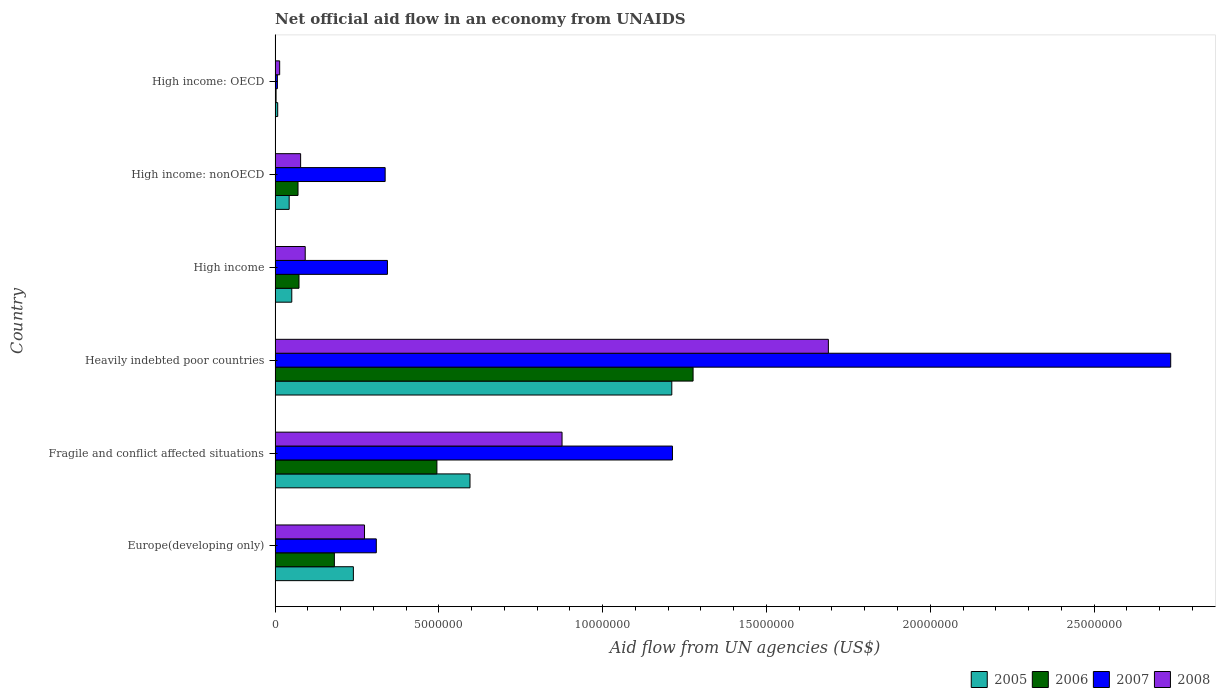Are the number of bars per tick equal to the number of legend labels?
Your answer should be very brief. Yes. How many bars are there on the 6th tick from the top?
Offer a very short reply. 4. How many bars are there on the 1st tick from the bottom?
Offer a terse response. 4. What is the label of the 6th group of bars from the top?
Offer a terse response. Europe(developing only). In how many cases, is the number of bars for a given country not equal to the number of legend labels?
Provide a succinct answer. 0. What is the net official aid flow in 2006 in Europe(developing only)?
Make the answer very short. 1.81e+06. Across all countries, what is the maximum net official aid flow in 2008?
Provide a succinct answer. 1.69e+07. In which country was the net official aid flow in 2005 maximum?
Keep it short and to the point. Heavily indebted poor countries. In which country was the net official aid flow in 2006 minimum?
Make the answer very short. High income: OECD. What is the total net official aid flow in 2006 in the graph?
Ensure brevity in your answer.  2.10e+07. What is the difference between the net official aid flow in 2008 in High income and that in High income: OECD?
Ensure brevity in your answer.  7.80e+05. What is the difference between the net official aid flow in 2007 in Fragile and conflict affected situations and the net official aid flow in 2008 in Europe(developing only)?
Your answer should be compact. 9.40e+06. What is the average net official aid flow in 2008 per country?
Make the answer very short. 5.04e+06. What is the difference between the net official aid flow in 2008 and net official aid flow in 2005 in Heavily indebted poor countries?
Give a very brief answer. 4.78e+06. What is the ratio of the net official aid flow in 2006 in Fragile and conflict affected situations to that in High income: OECD?
Provide a succinct answer. 164.67. Is the net official aid flow in 2006 in Fragile and conflict affected situations less than that in High income: nonOECD?
Make the answer very short. No. What is the difference between the highest and the second highest net official aid flow in 2007?
Offer a terse response. 1.52e+07. What is the difference between the highest and the lowest net official aid flow in 2007?
Provide a succinct answer. 2.73e+07. In how many countries, is the net official aid flow in 2007 greater than the average net official aid flow in 2007 taken over all countries?
Keep it short and to the point. 2. Is it the case that in every country, the sum of the net official aid flow in 2008 and net official aid flow in 2006 is greater than the sum of net official aid flow in 2005 and net official aid flow in 2007?
Your response must be concise. No. What does the 1st bar from the top in High income: OECD represents?
Your answer should be very brief. 2008. How many bars are there?
Ensure brevity in your answer.  24. Are all the bars in the graph horizontal?
Offer a terse response. Yes. What is the difference between two consecutive major ticks on the X-axis?
Keep it short and to the point. 5.00e+06. Are the values on the major ticks of X-axis written in scientific E-notation?
Your answer should be compact. No. Does the graph contain any zero values?
Keep it short and to the point. No. Where does the legend appear in the graph?
Your response must be concise. Bottom right. How many legend labels are there?
Make the answer very short. 4. What is the title of the graph?
Make the answer very short. Net official aid flow in an economy from UNAIDS. Does "2011" appear as one of the legend labels in the graph?
Your response must be concise. No. What is the label or title of the X-axis?
Provide a short and direct response. Aid flow from UN agencies (US$). What is the label or title of the Y-axis?
Provide a succinct answer. Country. What is the Aid flow from UN agencies (US$) of 2005 in Europe(developing only)?
Your answer should be compact. 2.39e+06. What is the Aid flow from UN agencies (US$) in 2006 in Europe(developing only)?
Give a very brief answer. 1.81e+06. What is the Aid flow from UN agencies (US$) of 2007 in Europe(developing only)?
Provide a succinct answer. 3.09e+06. What is the Aid flow from UN agencies (US$) of 2008 in Europe(developing only)?
Offer a terse response. 2.73e+06. What is the Aid flow from UN agencies (US$) of 2005 in Fragile and conflict affected situations?
Make the answer very short. 5.95e+06. What is the Aid flow from UN agencies (US$) of 2006 in Fragile and conflict affected situations?
Provide a short and direct response. 4.94e+06. What is the Aid flow from UN agencies (US$) in 2007 in Fragile and conflict affected situations?
Give a very brief answer. 1.21e+07. What is the Aid flow from UN agencies (US$) of 2008 in Fragile and conflict affected situations?
Your answer should be very brief. 8.76e+06. What is the Aid flow from UN agencies (US$) in 2005 in Heavily indebted poor countries?
Provide a short and direct response. 1.21e+07. What is the Aid flow from UN agencies (US$) in 2006 in Heavily indebted poor countries?
Ensure brevity in your answer.  1.28e+07. What is the Aid flow from UN agencies (US$) in 2007 in Heavily indebted poor countries?
Provide a short and direct response. 2.73e+07. What is the Aid flow from UN agencies (US$) of 2008 in Heavily indebted poor countries?
Your answer should be very brief. 1.69e+07. What is the Aid flow from UN agencies (US$) in 2005 in High income?
Give a very brief answer. 5.10e+05. What is the Aid flow from UN agencies (US$) in 2006 in High income?
Offer a terse response. 7.30e+05. What is the Aid flow from UN agencies (US$) of 2007 in High income?
Provide a succinct answer. 3.43e+06. What is the Aid flow from UN agencies (US$) of 2008 in High income?
Keep it short and to the point. 9.20e+05. What is the Aid flow from UN agencies (US$) of 2007 in High income: nonOECD?
Offer a very short reply. 3.36e+06. What is the Aid flow from UN agencies (US$) of 2008 in High income: nonOECD?
Provide a succinct answer. 7.80e+05. What is the Aid flow from UN agencies (US$) in 2006 in High income: OECD?
Offer a terse response. 3.00e+04. What is the Aid flow from UN agencies (US$) of 2008 in High income: OECD?
Provide a succinct answer. 1.40e+05. Across all countries, what is the maximum Aid flow from UN agencies (US$) of 2005?
Provide a succinct answer. 1.21e+07. Across all countries, what is the maximum Aid flow from UN agencies (US$) of 2006?
Keep it short and to the point. 1.28e+07. Across all countries, what is the maximum Aid flow from UN agencies (US$) in 2007?
Your answer should be compact. 2.73e+07. Across all countries, what is the maximum Aid flow from UN agencies (US$) in 2008?
Provide a short and direct response. 1.69e+07. Across all countries, what is the minimum Aid flow from UN agencies (US$) of 2005?
Keep it short and to the point. 8.00e+04. Across all countries, what is the minimum Aid flow from UN agencies (US$) in 2006?
Offer a very short reply. 3.00e+04. Across all countries, what is the minimum Aid flow from UN agencies (US$) of 2008?
Offer a very short reply. 1.40e+05. What is the total Aid flow from UN agencies (US$) of 2005 in the graph?
Your answer should be very brief. 2.15e+07. What is the total Aid flow from UN agencies (US$) of 2006 in the graph?
Offer a terse response. 2.10e+07. What is the total Aid flow from UN agencies (US$) in 2007 in the graph?
Your answer should be very brief. 4.94e+07. What is the total Aid flow from UN agencies (US$) of 2008 in the graph?
Offer a terse response. 3.02e+07. What is the difference between the Aid flow from UN agencies (US$) of 2005 in Europe(developing only) and that in Fragile and conflict affected situations?
Make the answer very short. -3.56e+06. What is the difference between the Aid flow from UN agencies (US$) of 2006 in Europe(developing only) and that in Fragile and conflict affected situations?
Your answer should be compact. -3.13e+06. What is the difference between the Aid flow from UN agencies (US$) of 2007 in Europe(developing only) and that in Fragile and conflict affected situations?
Make the answer very short. -9.04e+06. What is the difference between the Aid flow from UN agencies (US$) in 2008 in Europe(developing only) and that in Fragile and conflict affected situations?
Offer a terse response. -6.03e+06. What is the difference between the Aid flow from UN agencies (US$) of 2005 in Europe(developing only) and that in Heavily indebted poor countries?
Your answer should be very brief. -9.72e+06. What is the difference between the Aid flow from UN agencies (US$) in 2006 in Europe(developing only) and that in Heavily indebted poor countries?
Provide a succinct answer. -1.10e+07. What is the difference between the Aid flow from UN agencies (US$) of 2007 in Europe(developing only) and that in Heavily indebted poor countries?
Provide a succinct answer. -2.42e+07. What is the difference between the Aid flow from UN agencies (US$) of 2008 in Europe(developing only) and that in Heavily indebted poor countries?
Keep it short and to the point. -1.42e+07. What is the difference between the Aid flow from UN agencies (US$) in 2005 in Europe(developing only) and that in High income?
Your answer should be compact. 1.88e+06. What is the difference between the Aid flow from UN agencies (US$) of 2006 in Europe(developing only) and that in High income?
Your answer should be very brief. 1.08e+06. What is the difference between the Aid flow from UN agencies (US$) of 2007 in Europe(developing only) and that in High income?
Ensure brevity in your answer.  -3.40e+05. What is the difference between the Aid flow from UN agencies (US$) of 2008 in Europe(developing only) and that in High income?
Your response must be concise. 1.81e+06. What is the difference between the Aid flow from UN agencies (US$) of 2005 in Europe(developing only) and that in High income: nonOECD?
Provide a succinct answer. 1.96e+06. What is the difference between the Aid flow from UN agencies (US$) of 2006 in Europe(developing only) and that in High income: nonOECD?
Offer a very short reply. 1.11e+06. What is the difference between the Aid flow from UN agencies (US$) of 2008 in Europe(developing only) and that in High income: nonOECD?
Your answer should be compact. 1.95e+06. What is the difference between the Aid flow from UN agencies (US$) in 2005 in Europe(developing only) and that in High income: OECD?
Your answer should be very brief. 2.31e+06. What is the difference between the Aid flow from UN agencies (US$) in 2006 in Europe(developing only) and that in High income: OECD?
Make the answer very short. 1.78e+06. What is the difference between the Aid flow from UN agencies (US$) in 2007 in Europe(developing only) and that in High income: OECD?
Your answer should be very brief. 3.02e+06. What is the difference between the Aid flow from UN agencies (US$) in 2008 in Europe(developing only) and that in High income: OECD?
Ensure brevity in your answer.  2.59e+06. What is the difference between the Aid flow from UN agencies (US$) of 2005 in Fragile and conflict affected situations and that in Heavily indebted poor countries?
Keep it short and to the point. -6.16e+06. What is the difference between the Aid flow from UN agencies (US$) of 2006 in Fragile and conflict affected situations and that in Heavily indebted poor countries?
Give a very brief answer. -7.82e+06. What is the difference between the Aid flow from UN agencies (US$) of 2007 in Fragile and conflict affected situations and that in Heavily indebted poor countries?
Your answer should be compact. -1.52e+07. What is the difference between the Aid flow from UN agencies (US$) in 2008 in Fragile and conflict affected situations and that in Heavily indebted poor countries?
Provide a succinct answer. -8.13e+06. What is the difference between the Aid flow from UN agencies (US$) in 2005 in Fragile and conflict affected situations and that in High income?
Ensure brevity in your answer.  5.44e+06. What is the difference between the Aid flow from UN agencies (US$) of 2006 in Fragile and conflict affected situations and that in High income?
Keep it short and to the point. 4.21e+06. What is the difference between the Aid flow from UN agencies (US$) in 2007 in Fragile and conflict affected situations and that in High income?
Provide a short and direct response. 8.70e+06. What is the difference between the Aid flow from UN agencies (US$) in 2008 in Fragile and conflict affected situations and that in High income?
Offer a terse response. 7.84e+06. What is the difference between the Aid flow from UN agencies (US$) in 2005 in Fragile and conflict affected situations and that in High income: nonOECD?
Make the answer very short. 5.52e+06. What is the difference between the Aid flow from UN agencies (US$) of 2006 in Fragile and conflict affected situations and that in High income: nonOECD?
Provide a succinct answer. 4.24e+06. What is the difference between the Aid flow from UN agencies (US$) of 2007 in Fragile and conflict affected situations and that in High income: nonOECD?
Make the answer very short. 8.77e+06. What is the difference between the Aid flow from UN agencies (US$) of 2008 in Fragile and conflict affected situations and that in High income: nonOECD?
Ensure brevity in your answer.  7.98e+06. What is the difference between the Aid flow from UN agencies (US$) of 2005 in Fragile and conflict affected situations and that in High income: OECD?
Give a very brief answer. 5.87e+06. What is the difference between the Aid flow from UN agencies (US$) in 2006 in Fragile and conflict affected situations and that in High income: OECD?
Keep it short and to the point. 4.91e+06. What is the difference between the Aid flow from UN agencies (US$) in 2007 in Fragile and conflict affected situations and that in High income: OECD?
Offer a very short reply. 1.21e+07. What is the difference between the Aid flow from UN agencies (US$) in 2008 in Fragile and conflict affected situations and that in High income: OECD?
Provide a short and direct response. 8.62e+06. What is the difference between the Aid flow from UN agencies (US$) of 2005 in Heavily indebted poor countries and that in High income?
Your response must be concise. 1.16e+07. What is the difference between the Aid flow from UN agencies (US$) of 2006 in Heavily indebted poor countries and that in High income?
Provide a succinct answer. 1.20e+07. What is the difference between the Aid flow from UN agencies (US$) of 2007 in Heavily indebted poor countries and that in High income?
Ensure brevity in your answer.  2.39e+07. What is the difference between the Aid flow from UN agencies (US$) of 2008 in Heavily indebted poor countries and that in High income?
Your answer should be very brief. 1.60e+07. What is the difference between the Aid flow from UN agencies (US$) in 2005 in Heavily indebted poor countries and that in High income: nonOECD?
Give a very brief answer. 1.17e+07. What is the difference between the Aid flow from UN agencies (US$) in 2006 in Heavily indebted poor countries and that in High income: nonOECD?
Make the answer very short. 1.21e+07. What is the difference between the Aid flow from UN agencies (US$) in 2007 in Heavily indebted poor countries and that in High income: nonOECD?
Your response must be concise. 2.40e+07. What is the difference between the Aid flow from UN agencies (US$) of 2008 in Heavily indebted poor countries and that in High income: nonOECD?
Provide a succinct answer. 1.61e+07. What is the difference between the Aid flow from UN agencies (US$) in 2005 in Heavily indebted poor countries and that in High income: OECD?
Your answer should be very brief. 1.20e+07. What is the difference between the Aid flow from UN agencies (US$) of 2006 in Heavily indebted poor countries and that in High income: OECD?
Your answer should be very brief. 1.27e+07. What is the difference between the Aid flow from UN agencies (US$) in 2007 in Heavily indebted poor countries and that in High income: OECD?
Your answer should be very brief. 2.73e+07. What is the difference between the Aid flow from UN agencies (US$) in 2008 in Heavily indebted poor countries and that in High income: OECD?
Offer a very short reply. 1.68e+07. What is the difference between the Aid flow from UN agencies (US$) in 2005 in High income and that in High income: nonOECD?
Offer a very short reply. 8.00e+04. What is the difference between the Aid flow from UN agencies (US$) of 2006 in High income and that in High income: nonOECD?
Provide a succinct answer. 3.00e+04. What is the difference between the Aid flow from UN agencies (US$) in 2007 in High income and that in High income: nonOECD?
Your response must be concise. 7.00e+04. What is the difference between the Aid flow from UN agencies (US$) of 2008 in High income and that in High income: nonOECD?
Keep it short and to the point. 1.40e+05. What is the difference between the Aid flow from UN agencies (US$) of 2006 in High income and that in High income: OECD?
Keep it short and to the point. 7.00e+05. What is the difference between the Aid flow from UN agencies (US$) in 2007 in High income and that in High income: OECD?
Offer a very short reply. 3.36e+06. What is the difference between the Aid flow from UN agencies (US$) in 2008 in High income and that in High income: OECD?
Give a very brief answer. 7.80e+05. What is the difference between the Aid flow from UN agencies (US$) of 2005 in High income: nonOECD and that in High income: OECD?
Keep it short and to the point. 3.50e+05. What is the difference between the Aid flow from UN agencies (US$) of 2006 in High income: nonOECD and that in High income: OECD?
Offer a very short reply. 6.70e+05. What is the difference between the Aid flow from UN agencies (US$) of 2007 in High income: nonOECD and that in High income: OECD?
Ensure brevity in your answer.  3.29e+06. What is the difference between the Aid flow from UN agencies (US$) of 2008 in High income: nonOECD and that in High income: OECD?
Your response must be concise. 6.40e+05. What is the difference between the Aid flow from UN agencies (US$) in 2005 in Europe(developing only) and the Aid flow from UN agencies (US$) in 2006 in Fragile and conflict affected situations?
Give a very brief answer. -2.55e+06. What is the difference between the Aid flow from UN agencies (US$) in 2005 in Europe(developing only) and the Aid flow from UN agencies (US$) in 2007 in Fragile and conflict affected situations?
Give a very brief answer. -9.74e+06. What is the difference between the Aid flow from UN agencies (US$) in 2005 in Europe(developing only) and the Aid flow from UN agencies (US$) in 2008 in Fragile and conflict affected situations?
Offer a terse response. -6.37e+06. What is the difference between the Aid flow from UN agencies (US$) in 2006 in Europe(developing only) and the Aid flow from UN agencies (US$) in 2007 in Fragile and conflict affected situations?
Keep it short and to the point. -1.03e+07. What is the difference between the Aid flow from UN agencies (US$) in 2006 in Europe(developing only) and the Aid flow from UN agencies (US$) in 2008 in Fragile and conflict affected situations?
Offer a terse response. -6.95e+06. What is the difference between the Aid flow from UN agencies (US$) of 2007 in Europe(developing only) and the Aid flow from UN agencies (US$) of 2008 in Fragile and conflict affected situations?
Offer a terse response. -5.67e+06. What is the difference between the Aid flow from UN agencies (US$) of 2005 in Europe(developing only) and the Aid flow from UN agencies (US$) of 2006 in Heavily indebted poor countries?
Offer a terse response. -1.04e+07. What is the difference between the Aid flow from UN agencies (US$) in 2005 in Europe(developing only) and the Aid flow from UN agencies (US$) in 2007 in Heavily indebted poor countries?
Offer a very short reply. -2.50e+07. What is the difference between the Aid flow from UN agencies (US$) of 2005 in Europe(developing only) and the Aid flow from UN agencies (US$) of 2008 in Heavily indebted poor countries?
Your answer should be compact. -1.45e+07. What is the difference between the Aid flow from UN agencies (US$) in 2006 in Europe(developing only) and the Aid flow from UN agencies (US$) in 2007 in Heavily indebted poor countries?
Provide a succinct answer. -2.55e+07. What is the difference between the Aid flow from UN agencies (US$) in 2006 in Europe(developing only) and the Aid flow from UN agencies (US$) in 2008 in Heavily indebted poor countries?
Offer a very short reply. -1.51e+07. What is the difference between the Aid flow from UN agencies (US$) of 2007 in Europe(developing only) and the Aid flow from UN agencies (US$) of 2008 in Heavily indebted poor countries?
Offer a very short reply. -1.38e+07. What is the difference between the Aid flow from UN agencies (US$) of 2005 in Europe(developing only) and the Aid flow from UN agencies (US$) of 2006 in High income?
Provide a short and direct response. 1.66e+06. What is the difference between the Aid flow from UN agencies (US$) of 2005 in Europe(developing only) and the Aid flow from UN agencies (US$) of 2007 in High income?
Make the answer very short. -1.04e+06. What is the difference between the Aid flow from UN agencies (US$) in 2005 in Europe(developing only) and the Aid flow from UN agencies (US$) in 2008 in High income?
Offer a terse response. 1.47e+06. What is the difference between the Aid flow from UN agencies (US$) in 2006 in Europe(developing only) and the Aid flow from UN agencies (US$) in 2007 in High income?
Keep it short and to the point. -1.62e+06. What is the difference between the Aid flow from UN agencies (US$) of 2006 in Europe(developing only) and the Aid flow from UN agencies (US$) of 2008 in High income?
Offer a very short reply. 8.90e+05. What is the difference between the Aid flow from UN agencies (US$) in 2007 in Europe(developing only) and the Aid flow from UN agencies (US$) in 2008 in High income?
Keep it short and to the point. 2.17e+06. What is the difference between the Aid flow from UN agencies (US$) of 2005 in Europe(developing only) and the Aid flow from UN agencies (US$) of 2006 in High income: nonOECD?
Give a very brief answer. 1.69e+06. What is the difference between the Aid flow from UN agencies (US$) in 2005 in Europe(developing only) and the Aid flow from UN agencies (US$) in 2007 in High income: nonOECD?
Your response must be concise. -9.70e+05. What is the difference between the Aid flow from UN agencies (US$) in 2005 in Europe(developing only) and the Aid flow from UN agencies (US$) in 2008 in High income: nonOECD?
Ensure brevity in your answer.  1.61e+06. What is the difference between the Aid flow from UN agencies (US$) in 2006 in Europe(developing only) and the Aid flow from UN agencies (US$) in 2007 in High income: nonOECD?
Make the answer very short. -1.55e+06. What is the difference between the Aid flow from UN agencies (US$) in 2006 in Europe(developing only) and the Aid flow from UN agencies (US$) in 2008 in High income: nonOECD?
Provide a succinct answer. 1.03e+06. What is the difference between the Aid flow from UN agencies (US$) in 2007 in Europe(developing only) and the Aid flow from UN agencies (US$) in 2008 in High income: nonOECD?
Give a very brief answer. 2.31e+06. What is the difference between the Aid flow from UN agencies (US$) in 2005 in Europe(developing only) and the Aid flow from UN agencies (US$) in 2006 in High income: OECD?
Your answer should be very brief. 2.36e+06. What is the difference between the Aid flow from UN agencies (US$) of 2005 in Europe(developing only) and the Aid flow from UN agencies (US$) of 2007 in High income: OECD?
Provide a succinct answer. 2.32e+06. What is the difference between the Aid flow from UN agencies (US$) in 2005 in Europe(developing only) and the Aid flow from UN agencies (US$) in 2008 in High income: OECD?
Your answer should be very brief. 2.25e+06. What is the difference between the Aid flow from UN agencies (US$) in 2006 in Europe(developing only) and the Aid flow from UN agencies (US$) in 2007 in High income: OECD?
Make the answer very short. 1.74e+06. What is the difference between the Aid flow from UN agencies (US$) in 2006 in Europe(developing only) and the Aid flow from UN agencies (US$) in 2008 in High income: OECD?
Make the answer very short. 1.67e+06. What is the difference between the Aid flow from UN agencies (US$) in 2007 in Europe(developing only) and the Aid flow from UN agencies (US$) in 2008 in High income: OECD?
Your answer should be compact. 2.95e+06. What is the difference between the Aid flow from UN agencies (US$) of 2005 in Fragile and conflict affected situations and the Aid flow from UN agencies (US$) of 2006 in Heavily indebted poor countries?
Ensure brevity in your answer.  -6.81e+06. What is the difference between the Aid flow from UN agencies (US$) of 2005 in Fragile and conflict affected situations and the Aid flow from UN agencies (US$) of 2007 in Heavily indebted poor countries?
Give a very brief answer. -2.14e+07. What is the difference between the Aid flow from UN agencies (US$) in 2005 in Fragile and conflict affected situations and the Aid flow from UN agencies (US$) in 2008 in Heavily indebted poor countries?
Keep it short and to the point. -1.09e+07. What is the difference between the Aid flow from UN agencies (US$) of 2006 in Fragile and conflict affected situations and the Aid flow from UN agencies (US$) of 2007 in Heavily indebted poor countries?
Keep it short and to the point. -2.24e+07. What is the difference between the Aid flow from UN agencies (US$) of 2006 in Fragile and conflict affected situations and the Aid flow from UN agencies (US$) of 2008 in Heavily indebted poor countries?
Provide a succinct answer. -1.20e+07. What is the difference between the Aid flow from UN agencies (US$) of 2007 in Fragile and conflict affected situations and the Aid flow from UN agencies (US$) of 2008 in Heavily indebted poor countries?
Your response must be concise. -4.76e+06. What is the difference between the Aid flow from UN agencies (US$) of 2005 in Fragile and conflict affected situations and the Aid flow from UN agencies (US$) of 2006 in High income?
Offer a very short reply. 5.22e+06. What is the difference between the Aid flow from UN agencies (US$) of 2005 in Fragile and conflict affected situations and the Aid flow from UN agencies (US$) of 2007 in High income?
Give a very brief answer. 2.52e+06. What is the difference between the Aid flow from UN agencies (US$) of 2005 in Fragile and conflict affected situations and the Aid flow from UN agencies (US$) of 2008 in High income?
Keep it short and to the point. 5.03e+06. What is the difference between the Aid flow from UN agencies (US$) of 2006 in Fragile and conflict affected situations and the Aid flow from UN agencies (US$) of 2007 in High income?
Offer a very short reply. 1.51e+06. What is the difference between the Aid flow from UN agencies (US$) in 2006 in Fragile and conflict affected situations and the Aid flow from UN agencies (US$) in 2008 in High income?
Offer a very short reply. 4.02e+06. What is the difference between the Aid flow from UN agencies (US$) in 2007 in Fragile and conflict affected situations and the Aid flow from UN agencies (US$) in 2008 in High income?
Offer a terse response. 1.12e+07. What is the difference between the Aid flow from UN agencies (US$) in 2005 in Fragile and conflict affected situations and the Aid flow from UN agencies (US$) in 2006 in High income: nonOECD?
Offer a very short reply. 5.25e+06. What is the difference between the Aid flow from UN agencies (US$) of 2005 in Fragile and conflict affected situations and the Aid flow from UN agencies (US$) of 2007 in High income: nonOECD?
Your answer should be compact. 2.59e+06. What is the difference between the Aid flow from UN agencies (US$) of 2005 in Fragile and conflict affected situations and the Aid flow from UN agencies (US$) of 2008 in High income: nonOECD?
Provide a short and direct response. 5.17e+06. What is the difference between the Aid flow from UN agencies (US$) in 2006 in Fragile and conflict affected situations and the Aid flow from UN agencies (US$) in 2007 in High income: nonOECD?
Make the answer very short. 1.58e+06. What is the difference between the Aid flow from UN agencies (US$) of 2006 in Fragile and conflict affected situations and the Aid flow from UN agencies (US$) of 2008 in High income: nonOECD?
Your response must be concise. 4.16e+06. What is the difference between the Aid flow from UN agencies (US$) in 2007 in Fragile and conflict affected situations and the Aid flow from UN agencies (US$) in 2008 in High income: nonOECD?
Keep it short and to the point. 1.14e+07. What is the difference between the Aid flow from UN agencies (US$) of 2005 in Fragile and conflict affected situations and the Aid flow from UN agencies (US$) of 2006 in High income: OECD?
Offer a very short reply. 5.92e+06. What is the difference between the Aid flow from UN agencies (US$) in 2005 in Fragile and conflict affected situations and the Aid flow from UN agencies (US$) in 2007 in High income: OECD?
Provide a succinct answer. 5.88e+06. What is the difference between the Aid flow from UN agencies (US$) in 2005 in Fragile and conflict affected situations and the Aid flow from UN agencies (US$) in 2008 in High income: OECD?
Provide a short and direct response. 5.81e+06. What is the difference between the Aid flow from UN agencies (US$) of 2006 in Fragile and conflict affected situations and the Aid flow from UN agencies (US$) of 2007 in High income: OECD?
Keep it short and to the point. 4.87e+06. What is the difference between the Aid flow from UN agencies (US$) in 2006 in Fragile and conflict affected situations and the Aid flow from UN agencies (US$) in 2008 in High income: OECD?
Keep it short and to the point. 4.80e+06. What is the difference between the Aid flow from UN agencies (US$) in 2007 in Fragile and conflict affected situations and the Aid flow from UN agencies (US$) in 2008 in High income: OECD?
Keep it short and to the point. 1.20e+07. What is the difference between the Aid flow from UN agencies (US$) in 2005 in Heavily indebted poor countries and the Aid flow from UN agencies (US$) in 2006 in High income?
Your answer should be very brief. 1.14e+07. What is the difference between the Aid flow from UN agencies (US$) in 2005 in Heavily indebted poor countries and the Aid flow from UN agencies (US$) in 2007 in High income?
Make the answer very short. 8.68e+06. What is the difference between the Aid flow from UN agencies (US$) of 2005 in Heavily indebted poor countries and the Aid flow from UN agencies (US$) of 2008 in High income?
Keep it short and to the point. 1.12e+07. What is the difference between the Aid flow from UN agencies (US$) in 2006 in Heavily indebted poor countries and the Aid flow from UN agencies (US$) in 2007 in High income?
Your response must be concise. 9.33e+06. What is the difference between the Aid flow from UN agencies (US$) of 2006 in Heavily indebted poor countries and the Aid flow from UN agencies (US$) of 2008 in High income?
Provide a succinct answer. 1.18e+07. What is the difference between the Aid flow from UN agencies (US$) of 2007 in Heavily indebted poor countries and the Aid flow from UN agencies (US$) of 2008 in High income?
Make the answer very short. 2.64e+07. What is the difference between the Aid flow from UN agencies (US$) of 2005 in Heavily indebted poor countries and the Aid flow from UN agencies (US$) of 2006 in High income: nonOECD?
Provide a short and direct response. 1.14e+07. What is the difference between the Aid flow from UN agencies (US$) of 2005 in Heavily indebted poor countries and the Aid flow from UN agencies (US$) of 2007 in High income: nonOECD?
Your response must be concise. 8.75e+06. What is the difference between the Aid flow from UN agencies (US$) of 2005 in Heavily indebted poor countries and the Aid flow from UN agencies (US$) of 2008 in High income: nonOECD?
Make the answer very short. 1.13e+07. What is the difference between the Aid flow from UN agencies (US$) of 2006 in Heavily indebted poor countries and the Aid flow from UN agencies (US$) of 2007 in High income: nonOECD?
Your response must be concise. 9.40e+06. What is the difference between the Aid flow from UN agencies (US$) of 2006 in Heavily indebted poor countries and the Aid flow from UN agencies (US$) of 2008 in High income: nonOECD?
Your response must be concise. 1.20e+07. What is the difference between the Aid flow from UN agencies (US$) in 2007 in Heavily indebted poor countries and the Aid flow from UN agencies (US$) in 2008 in High income: nonOECD?
Keep it short and to the point. 2.66e+07. What is the difference between the Aid flow from UN agencies (US$) of 2005 in Heavily indebted poor countries and the Aid flow from UN agencies (US$) of 2006 in High income: OECD?
Your answer should be compact. 1.21e+07. What is the difference between the Aid flow from UN agencies (US$) in 2005 in Heavily indebted poor countries and the Aid flow from UN agencies (US$) in 2007 in High income: OECD?
Make the answer very short. 1.20e+07. What is the difference between the Aid flow from UN agencies (US$) of 2005 in Heavily indebted poor countries and the Aid flow from UN agencies (US$) of 2008 in High income: OECD?
Provide a short and direct response. 1.20e+07. What is the difference between the Aid flow from UN agencies (US$) of 2006 in Heavily indebted poor countries and the Aid flow from UN agencies (US$) of 2007 in High income: OECD?
Offer a terse response. 1.27e+07. What is the difference between the Aid flow from UN agencies (US$) in 2006 in Heavily indebted poor countries and the Aid flow from UN agencies (US$) in 2008 in High income: OECD?
Your answer should be compact. 1.26e+07. What is the difference between the Aid flow from UN agencies (US$) in 2007 in Heavily indebted poor countries and the Aid flow from UN agencies (US$) in 2008 in High income: OECD?
Provide a short and direct response. 2.72e+07. What is the difference between the Aid flow from UN agencies (US$) in 2005 in High income and the Aid flow from UN agencies (US$) in 2006 in High income: nonOECD?
Provide a short and direct response. -1.90e+05. What is the difference between the Aid flow from UN agencies (US$) in 2005 in High income and the Aid flow from UN agencies (US$) in 2007 in High income: nonOECD?
Offer a very short reply. -2.85e+06. What is the difference between the Aid flow from UN agencies (US$) in 2005 in High income and the Aid flow from UN agencies (US$) in 2008 in High income: nonOECD?
Provide a short and direct response. -2.70e+05. What is the difference between the Aid flow from UN agencies (US$) in 2006 in High income and the Aid flow from UN agencies (US$) in 2007 in High income: nonOECD?
Your response must be concise. -2.63e+06. What is the difference between the Aid flow from UN agencies (US$) of 2007 in High income and the Aid flow from UN agencies (US$) of 2008 in High income: nonOECD?
Offer a terse response. 2.65e+06. What is the difference between the Aid flow from UN agencies (US$) of 2005 in High income and the Aid flow from UN agencies (US$) of 2006 in High income: OECD?
Offer a terse response. 4.80e+05. What is the difference between the Aid flow from UN agencies (US$) of 2005 in High income and the Aid flow from UN agencies (US$) of 2007 in High income: OECD?
Ensure brevity in your answer.  4.40e+05. What is the difference between the Aid flow from UN agencies (US$) of 2006 in High income and the Aid flow from UN agencies (US$) of 2007 in High income: OECD?
Your answer should be very brief. 6.60e+05. What is the difference between the Aid flow from UN agencies (US$) in 2006 in High income and the Aid flow from UN agencies (US$) in 2008 in High income: OECD?
Your answer should be very brief. 5.90e+05. What is the difference between the Aid flow from UN agencies (US$) of 2007 in High income and the Aid flow from UN agencies (US$) of 2008 in High income: OECD?
Keep it short and to the point. 3.29e+06. What is the difference between the Aid flow from UN agencies (US$) of 2005 in High income: nonOECD and the Aid flow from UN agencies (US$) of 2008 in High income: OECD?
Provide a short and direct response. 2.90e+05. What is the difference between the Aid flow from UN agencies (US$) in 2006 in High income: nonOECD and the Aid flow from UN agencies (US$) in 2007 in High income: OECD?
Provide a short and direct response. 6.30e+05. What is the difference between the Aid flow from UN agencies (US$) in 2006 in High income: nonOECD and the Aid flow from UN agencies (US$) in 2008 in High income: OECD?
Offer a very short reply. 5.60e+05. What is the difference between the Aid flow from UN agencies (US$) of 2007 in High income: nonOECD and the Aid flow from UN agencies (US$) of 2008 in High income: OECD?
Provide a succinct answer. 3.22e+06. What is the average Aid flow from UN agencies (US$) of 2005 per country?
Ensure brevity in your answer.  3.58e+06. What is the average Aid flow from UN agencies (US$) of 2006 per country?
Give a very brief answer. 3.50e+06. What is the average Aid flow from UN agencies (US$) of 2007 per country?
Your response must be concise. 8.24e+06. What is the average Aid flow from UN agencies (US$) of 2008 per country?
Make the answer very short. 5.04e+06. What is the difference between the Aid flow from UN agencies (US$) in 2005 and Aid flow from UN agencies (US$) in 2006 in Europe(developing only)?
Provide a succinct answer. 5.80e+05. What is the difference between the Aid flow from UN agencies (US$) of 2005 and Aid flow from UN agencies (US$) of 2007 in Europe(developing only)?
Your answer should be compact. -7.00e+05. What is the difference between the Aid flow from UN agencies (US$) in 2005 and Aid flow from UN agencies (US$) in 2008 in Europe(developing only)?
Your answer should be compact. -3.40e+05. What is the difference between the Aid flow from UN agencies (US$) in 2006 and Aid flow from UN agencies (US$) in 2007 in Europe(developing only)?
Your response must be concise. -1.28e+06. What is the difference between the Aid flow from UN agencies (US$) of 2006 and Aid flow from UN agencies (US$) of 2008 in Europe(developing only)?
Make the answer very short. -9.20e+05. What is the difference between the Aid flow from UN agencies (US$) of 2005 and Aid flow from UN agencies (US$) of 2006 in Fragile and conflict affected situations?
Give a very brief answer. 1.01e+06. What is the difference between the Aid flow from UN agencies (US$) in 2005 and Aid flow from UN agencies (US$) in 2007 in Fragile and conflict affected situations?
Provide a short and direct response. -6.18e+06. What is the difference between the Aid flow from UN agencies (US$) of 2005 and Aid flow from UN agencies (US$) of 2008 in Fragile and conflict affected situations?
Offer a very short reply. -2.81e+06. What is the difference between the Aid flow from UN agencies (US$) in 2006 and Aid flow from UN agencies (US$) in 2007 in Fragile and conflict affected situations?
Your response must be concise. -7.19e+06. What is the difference between the Aid flow from UN agencies (US$) in 2006 and Aid flow from UN agencies (US$) in 2008 in Fragile and conflict affected situations?
Keep it short and to the point. -3.82e+06. What is the difference between the Aid flow from UN agencies (US$) in 2007 and Aid flow from UN agencies (US$) in 2008 in Fragile and conflict affected situations?
Provide a short and direct response. 3.37e+06. What is the difference between the Aid flow from UN agencies (US$) in 2005 and Aid flow from UN agencies (US$) in 2006 in Heavily indebted poor countries?
Offer a very short reply. -6.50e+05. What is the difference between the Aid flow from UN agencies (US$) of 2005 and Aid flow from UN agencies (US$) of 2007 in Heavily indebted poor countries?
Ensure brevity in your answer.  -1.52e+07. What is the difference between the Aid flow from UN agencies (US$) in 2005 and Aid flow from UN agencies (US$) in 2008 in Heavily indebted poor countries?
Make the answer very short. -4.78e+06. What is the difference between the Aid flow from UN agencies (US$) of 2006 and Aid flow from UN agencies (US$) of 2007 in Heavily indebted poor countries?
Offer a terse response. -1.46e+07. What is the difference between the Aid flow from UN agencies (US$) of 2006 and Aid flow from UN agencies (US$) of 2008 in Heavily indebted poor countries?
Keep it short and to the point. -4.13e+06. What is the difference between the Aid flow from UN agencies (US$) in 2007 and Aid flow from UN agencies (US$) in 2008 in Heavily indebted poor countries?
Your answer should be very brief. 1.04e+07. What is the difference between the Aid flow from UN agencies (US$) in 2005 and Aid flow from UN agencies (US$) in 2006 in High income?
Keep it short and to the point. -2.20e+05. What is the difference between the Aid flow from UN agencies (US$) in 2005 and Aid flow from UN agencies (US$) in 2007 in High income?
Provide a short and direct response. -2.92e+06. What is the difference between the Aid flow from UN agencies (US$) in 2005 and Aid flow from UN agencies (US$) in 2008 in High income?
Give a very brief answer. -4.10e+05. What is the difference between the Aid flow from UN agencies (US$) of 2006 and Aid flow from UN agencies (US$) of 2007 in High income?
Keep it short and to the point. -2.70e+06. What is the difference between the Aid flow from UN agencies (US$) in 2007 and Aid flow from UN agencies (US$) in 2008 in High income?
Provide a short and direct response. 2.51e+06. What is the difference between the Aid flow from UN agencies (US$) of 2005 and Aid flow from UN agencies (US$) of 2007 in High income: nonOECD?
Offer a terse response. -2.93e+06. What is the difference between the Aid flow from UN agencies (US$) in 2005 and Aid flow from UN agencies (US$) in 2008 in High income: nonOECD?
Your answer should be compact. -3.50e+05. What is the difference between the Aid flow from UN agencies (US$) in 2006 and Aid flow from UN agencies (US$) in 2007 in High income: nonOECD?
Provide a succinct answer. -2.66e+06. What is the difference between the Aid flow from UN agencies (US$) in 2007 and Aid flow from UN agencies (US$) in 2008 in High income: nonOECD?
Your answer should be compact. 2.58e+06. What is the difference between the Aid flow from UN agencies (US$) of 2005 and Aid flow from UN agencies (US$) of 2006 in High income: OECD?
Keep it short and to the point. 5.00e+04. What is the difference between the Aid flow from UN agencies (US$) in 2005 and Aid flow from UN agencies (US$) in 2008 in High income: OECD?
Offer a terse response. -6.00e+04. What is the difference between the Aid flow from UN agencies (US$) of 2006 and Aid flow from UN agencies (US$) of 2007 in High income: OECD?
Provide a succinct answer. -4.00e+04. What is the difference between the Aid flow from UN agencies (US$) of 2006 and Aid flow from UN agencies (US$) of 2008 in High income: OECD?
Keep it short and to the point. -1.10e+05. What is the ratio of the Aid flow from UN agencies (US$) of 2005 in Europe(developing only) to that in Fragile and conflict affected situations?
Give a very brief answer. 0.4. What is the ratio of the Aid flow from UN agencies (US$) in 2006 in Europe(developing only) to that in Fragile and conflict affected situations?
Offer a very short reply. 0.37. What is the ratio of the Aid flow from UN agencies (US$) of 2007 in Europe(developing only) to that in Fragile and conflict affected situations?
Offer a terse response. 0.25. What is the ratio of the Aid flow from UN agencies (US$) of 2008 in Europe(developing only) to that in Fragile and conflict affected situations?
Keep it short and to the point. 0.31. What is the ratio of the Aid flow from UN agencies (US$) in 2005 in Europe(developing only) to that in Heavily indebted poor countries?
Your answer should be compact. 0.2. What is the ratio of the Aid flow from UN agencies (US$) in 2006 in Europe(developing only) to that in Heavily indebted poor countries?
Give a very brief answer. 0.14. What is the ratio of the Aid flow from UN agencies (US$) in 2007 in Europe(developing only) to that in Heavily indebted poor countries?
Make the answer very short. 0.11. What is the ratio of the Aid flow from UN agencies (US$) of 2008 in Europe(developing only) to that in Heavily indebted poor countries?
Provide a short and direct response. 0.16. What is the ratio of the Aid flow from UN agencies (US$) of 2005 in Europe(developing only) to that in High income?
Offer a very short reply. 4.69. What is the ratio of the Aid flow from UN agencies (US$) of 2006 in Europe(developing only) to that in High income?
Your response must be concise. 2.48. What is the ratio of the Aid flow from UN agencies (US$) of 2007 in Europe(developing only) to that in High income?
Make the answer very short. 0.9. What is the ratio of the Aid flow from UN agencies (US$) of 2008 in Europe(developing only) to that in High income?
Provide a short and direct response. 2.97. What is the ratio of the Aid flow from UN agencies (US$) in 2005 in Europe(developing only) to that in High income: nonOECD?
Your response must be concise. 5.56. What is the ratio of the Aid flow from UN agencies (US$) in 2006 in Europe(developing only) to that in High income: nonOECD?
Make the answer very short. 2.59. What is the ratio of the Aid flow from UN agencies (US$) of 2007 in Europe(developing only) to that in High income: nonOECD?
Ensure brevity in your answer.  0.92. What is the ratio of the Aid flow from UN agencies (US$) in 2008 in Europe(developing only) to that in High income: nonOECD?
Give a very brief answer. 3.5. What is the ratio of the Aid flow from UN agencies (US$) of 2005 in Europe(developing only) to that in High income: OECD?
Your response must be concise. 29.88. What is the ratio of the Aid flow from UN agencies (US$) in 2006 in Europe(developing only) to that in High income: OECD?
Your answer should be very brief. 60.33. What is the ratio of the Aid flow from UN agencies (US$) of 2007 in Europe(developing only) to that in High income: OECD?
Your response must be concise. 44.14. What is the ratio of the Aid flow from UN agencies (US$) of 2008 in Europe(developing only) to that in High income: OECD?
Offer a terse response. 19.5. What is the ratio of the Aid flow from UN agencies (US$) of 2005 in Fragile and conflict affected situations to that in Heavily indebted poor countries?
Ensure brevity in your answer.  0.49. What is the ratio of the Aid flow from UN agencies (US$) of 2006 in Fragile and conflict affected situations to that in Heavily indebted poor countries?
Provide a succinct answer. 0.39. What is the ratio of the Aid flow from UN agencies (US$) of 2007 in Fragile and conflict affected situations to that in Heavily indebted poor countries?
Offer a very short reply. 0.44. What is the ratio of the Aid flow from UN agencies (US$) in 2008 in Fragile and conflict affected situations to that in Heavily indebted poor countries?
Your answer should be very brief. 0.52. What is the ratio of the Aid flow from UN agencies (US$) of 2005 in Fragile and conflict affected situations to that in High income?
Keep it short and to the point. 11.67. What is the ratio of the Aid flow from UN agencies (US$) of 2006 in Fragile and conflict affected situations to that in High income?
Your answer should be very brief. 6.77. What is the ratio of the Aid flow from UN agencies (US$) of 2007 in Fragile and conflict affected situations to that in High income?
Make the answer very short. 3.54. What is the ratio of the Aid flow from UN agencies (US$) in 2008 in Fragile and conflict affected situations to that in High income?
Your answer should be compact. 9.52. What is the ratio of the Aid flow from UN agencies (US$) in 2005 in Fragile and conflict affected situations to that in High income: nonOECD?
Provide a succinct answer. 13.84. What is the ratio of the Aid flow from UN agencies (US$) in 2006 in Fragile and conflict affected situations to that in High income: nonOECD?
Provide a succinct answer. 7.06. What is the ratio of the Aid flow from UN agencies (US$) of 2007 in Fragile and conflict affected situations to that in High income: nonOECD?
Provide a succinct answer. 3.61. What is the ratio of the Aid flow from UN agencies (US$) in 2008 in Fragile and conflict affected situations to that in High income: nonOECD?
Provide a succinct answer. 11.23. What is the ratio of the Aid flow from UN agencies (US$) in 2005 in Fragile and conflict affected situations to that in High income: OECD?
Ensure brevity in your answer.  74.38. What is the ratio of the Aid flow from UN agencies (US$) of 2006 in Fragile and conflict affected situations to that in High income: OECD?
Your response must be concise. 164.67. What is the ratio of the Aid flow from UN agencies (US$) of 2007 in Fragile and conflict affected situations to that in High income: OECD?
Give a very brief answer. 173.29. What is the ratio of the Aid flow from UN agencies (US$) of 2008 in Fragile and conflict affected situations to that in High income: OECD?
Keep it short and to the point. 62.57. What is the ratio of the Aid flow from UN agencies (US$) of 2005 in Heavily indebted poor countries to that in High income?
Your response must be concise. 23.75. What is the ratio of the Aid flow from UN agencies (US$) of 2006 in Heavily indebted poor countries to that in High income?
Provide a succinct answer. 17.48. What is the ratio of the Aid flow from UN agencies (US$) in 2007 in Heavily indebted poor countries to that in High income?
Keep it short and to the point. 7.97. What is the ratio of the Aid flow from UN agencies (US$) in 2008 in Heavily indebted poor countries to that in High income?
Your answer should be compact. 18.36. What is the ratio of the Aid flow from UN agencies (US$) of 2005 in Heavily indebted poor countries to that in High income: nonOECD?
Keep it short and to the point. 28.16. What is the ratio of the Aid flow from UN agencies (US$) in 2006 in Heavily indebted poor countries to that in High income: nonOECD?
Your response must be concise. 18.23. What is the ratio of the Aid flow from UN agencies (US$) of 2007 in Heavily indebted poor countries to that in High income: nonOECD?
Provide a short and direct response. 8.14. What is the ratio of the Aid flow from UN agencies (US$) of 2008 in Heavily indebted poor countries to that in High income: nonOECD?
Your answer should be compact. 21.65. What is the ratio of the Aid flow from UN agencies (US$) in 2005 in Heavily indebted poor countries to that in High income: OECD?
Your response must be concise. 151.38. What is the ratio of the Aid flow from UN agencies (US$) in 2006 in Heavily indebted poor countries to that in High income: OECD?
Offer a terse response. 425.33. What is the ratio of the Aid flow from UN agencies (US$) in 2007 in Heavily indebted poor countries to that in High income: OECD?
Your answer should be very brief. 390.57. What is the ratio of the Aid flow from UN agencies (US$) of 2008 in Heavily indebted poor countries to that in High income: OECD?
Your response must be concise. 120.64. What is the ratio of the Aid flow from UN agencies (US$) of 2005 in High income to that in High income: nonOECD?
Make the answer very short. 1.19. What is the ratio of the Aid flow from UN agencies (US$) of 2006 in High income to that in High income: nonOECD?
Your answer should be very brief. 1.04. What is the ratio of the Aid flow from UN agencies (US$) of 2007 in High income to that in High income: nonOECD?
Provide a succinct answer. 1.02. What is the ratio of the Aid flow from UN agencies (US$) of 2008 in High income to that in High income: nonOECD?
Provide a short and direct response. 1.18. What is the ratio of the Aid flow from UN agencies (US$) of 2005 in High income to that in High income: OECD?
Your answer should be compact. 6.38. What is the ratio of the Aid flow from UN agencies (US$) of 2006 in High income to that in High income: OECD?
Your answer should be very brief. 24.33. What is the ratio of the Aid flow from UN agencies (US$) of 2007 in High income to that in High income: OECD?
Offer a very short reply. 49. What is the ratio of the Aid flow from UN agencies (US$) in 2008 in High income to that in High income: OECD?
Keep it short and to the point. 6.57. What is the ratio of the Aid flow from UN agencies (US$) in 2005 in High income: nonOECD to that in High income: OECD?
Make the answer very short. 5.38. What is the ratio of the Aid flow from UN agencies (US$) of 2006 in High income: nonOECD to that in High income: OECD?
Your response must be concise. 23.33. What is the ratio of the Aid flow from UN agencies (US$) of 2008 in High income: nonOECD to that in High income: OECD?
Give a very brief answer. 5.57. What is the difference between the highest and the second highest Aid flow from UN agencies (US$) in 2005?
Offer a terse response. 6.16e+06. What is the difference between the highest and the second highest Aid flow from UN agencies (US$) of 2006?
Your answer should be compact. 7.82e+06. What is the difference between the highest and the second highest Aid flow from UN agencies (US$) of 2007?
Your response must be concise. 1.52e+07. What is the difference between the highest and the second highest Aid flow from UN agencies (US$) of 2008?
Make the answer very short. 8.13e+06. What is the difference between the highest and the lowest Aid flow from UN agencies (US$) in 2005?
Provide a short and direct response. 1.20e+07. What is the difference between the highest and the lowest Aid flow from UN agencies (US$) in 2006?
Provide a succinct answer. 1.27e+07. What is the difference between the highest and the lowest Aid flow from UN agencies (US$) in 2007?
Ensure brevity in your answer.  2.73e+07. What is the difference between the highest and the lowest Aid flow from UN agencies (US$) of 2008?
Offer a terse response. 1.68e+07. 